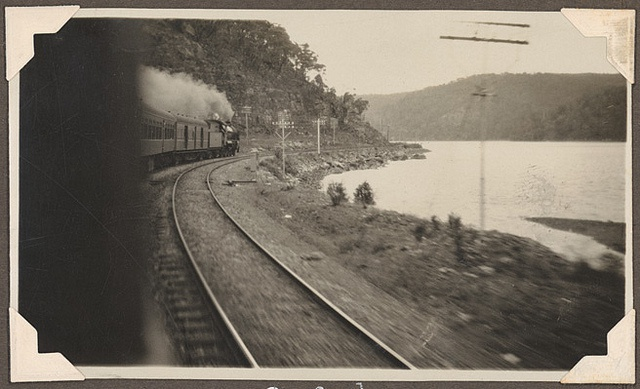Describe the objects in this image and their specific colors. I can see a train in gray and black tones in this image. 